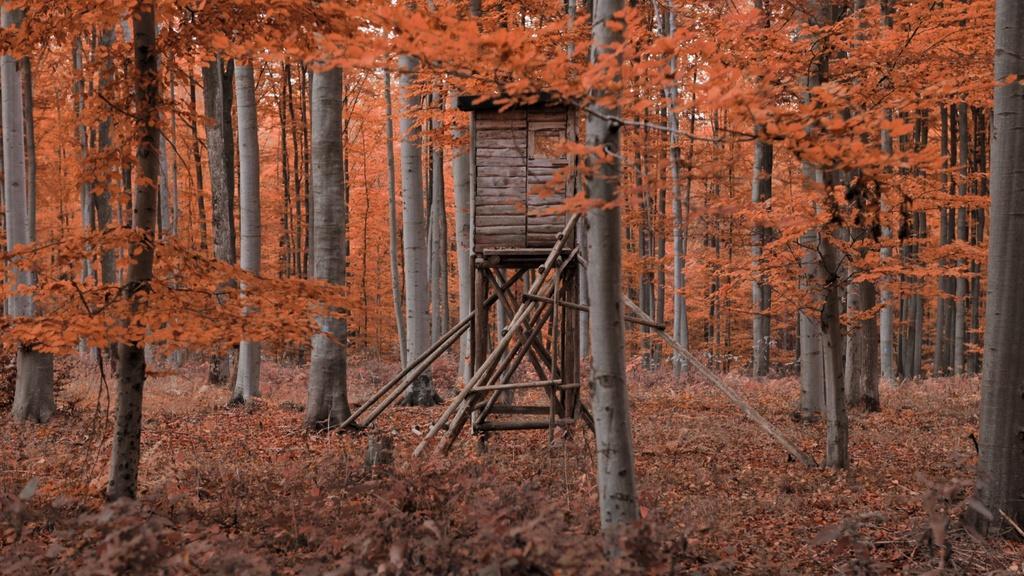How would you summarize this image in a sentence or two? In this image we can see there are some trees, grass and leaves on the ground, also we can see a wooden object which looks like a house. 